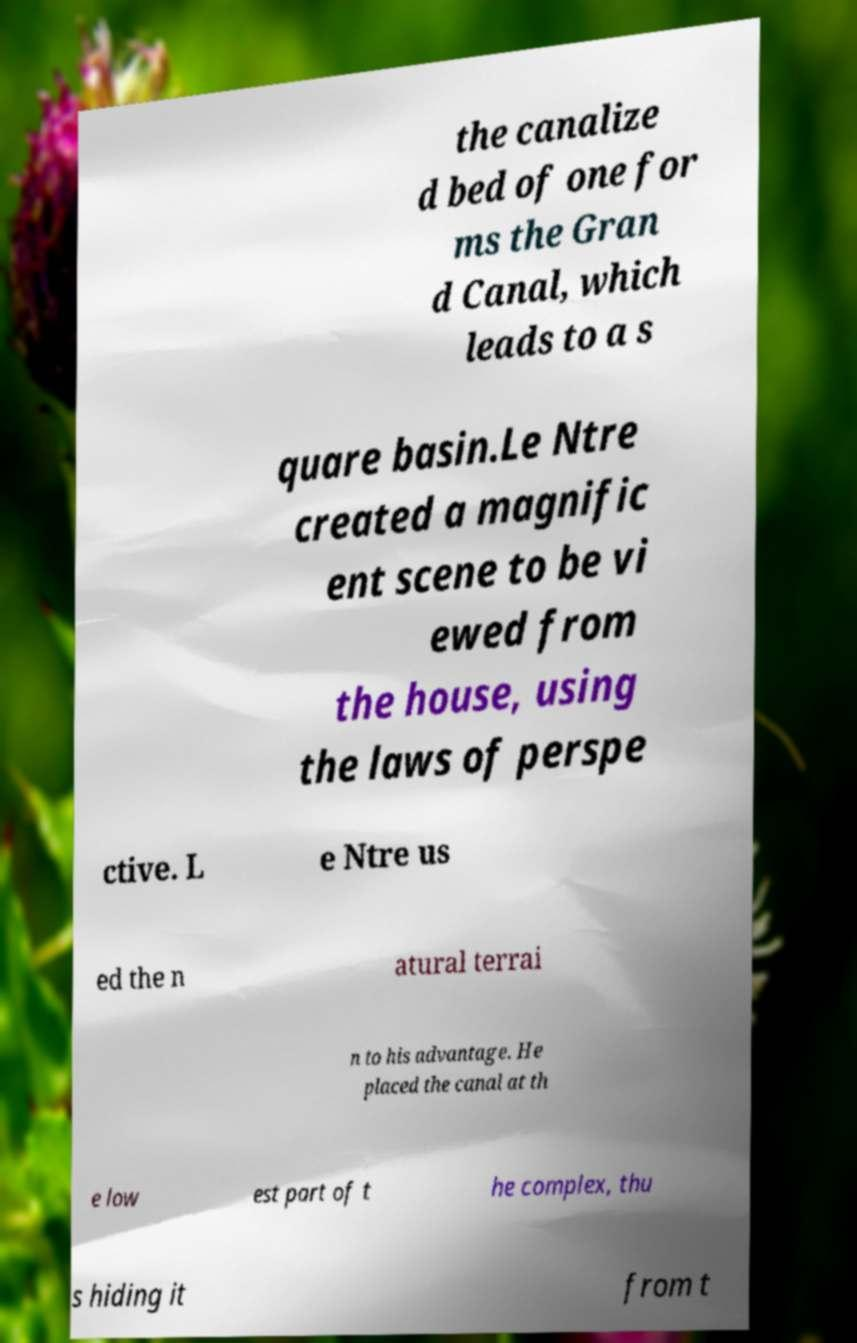Please read and relay the text visible in this image. What does it say? the canalize d bed of one for ms the Gran d Canal, which leads to a s quare basin.Le Ntre created a magnific ent scene to be vi ewed from the house, using the laws of perspe ctive. L e Ntre us ed the n atural terrai n to his advantage. He placed the canal at th e low est part of t he complex, thu s hiding it from t 